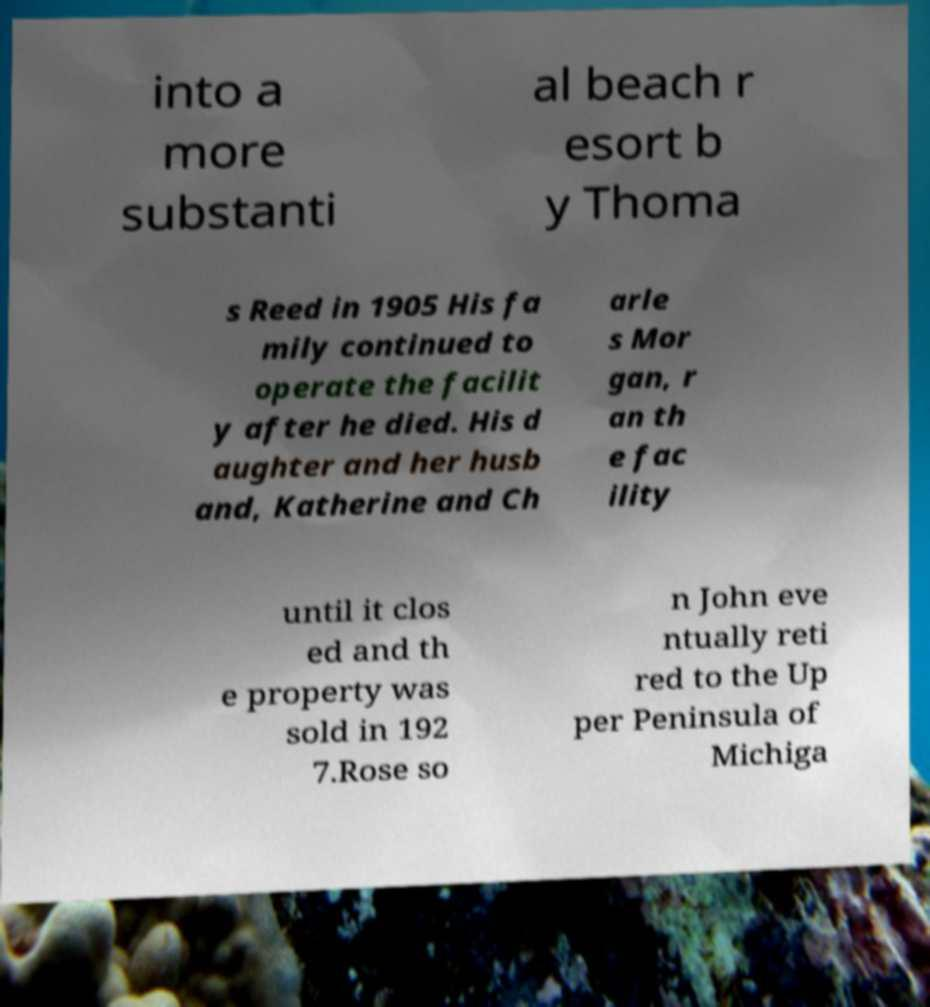Could you assist in decoding the text presented in this image and type it out clearly? into a more substanti al beach r esort b y Thoma s Reed in 1905 His fa mily continued to operate the facilit y after he died. His d aughter and her husb and, Katherine and Ch arle s Mor gan, r an th e fac ility until it clos ed and th e property was sold in 192 7.Rose so n John eve ntually reti red to the Up per Peninsula of Michiga 